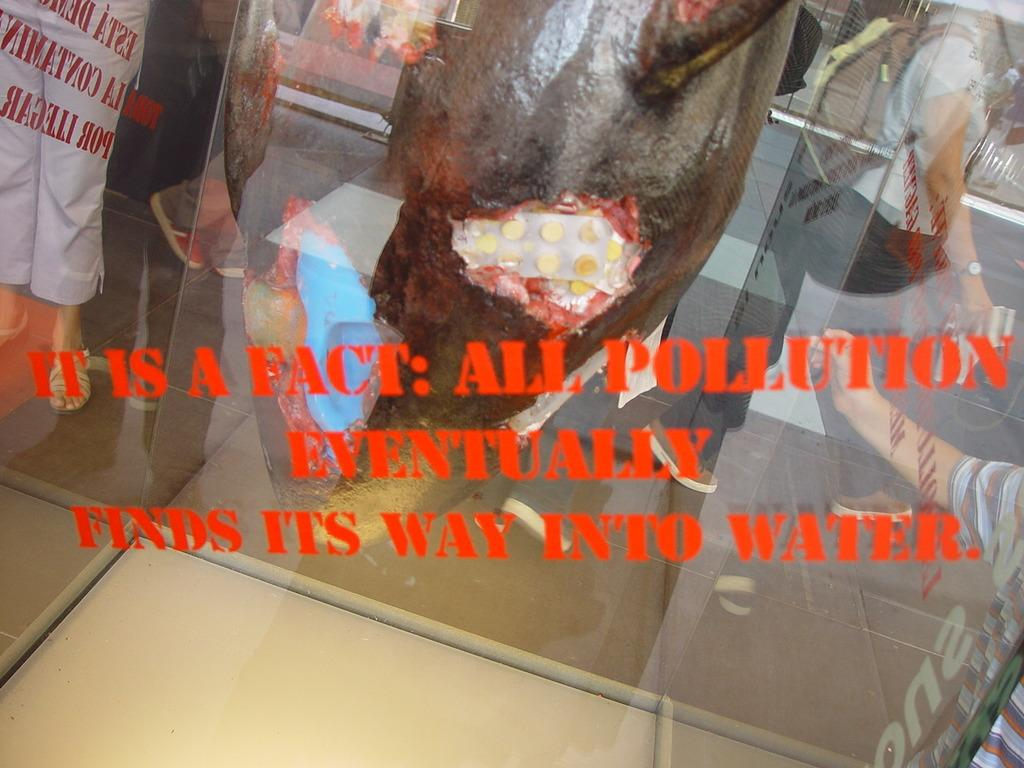What is covered with stickers in the image? There are stickers on a transparent glass material in the image. Can you describe the people in the image? There is a group of people standing in the image. What else can be seen in the image besides the stickers and people? There is an object in the image. What decision did the group of people make in the image? There is no indication of a decision being made by the group of people in the image. Where is the bedroom located in the image? There is no bedroom present in the image. 